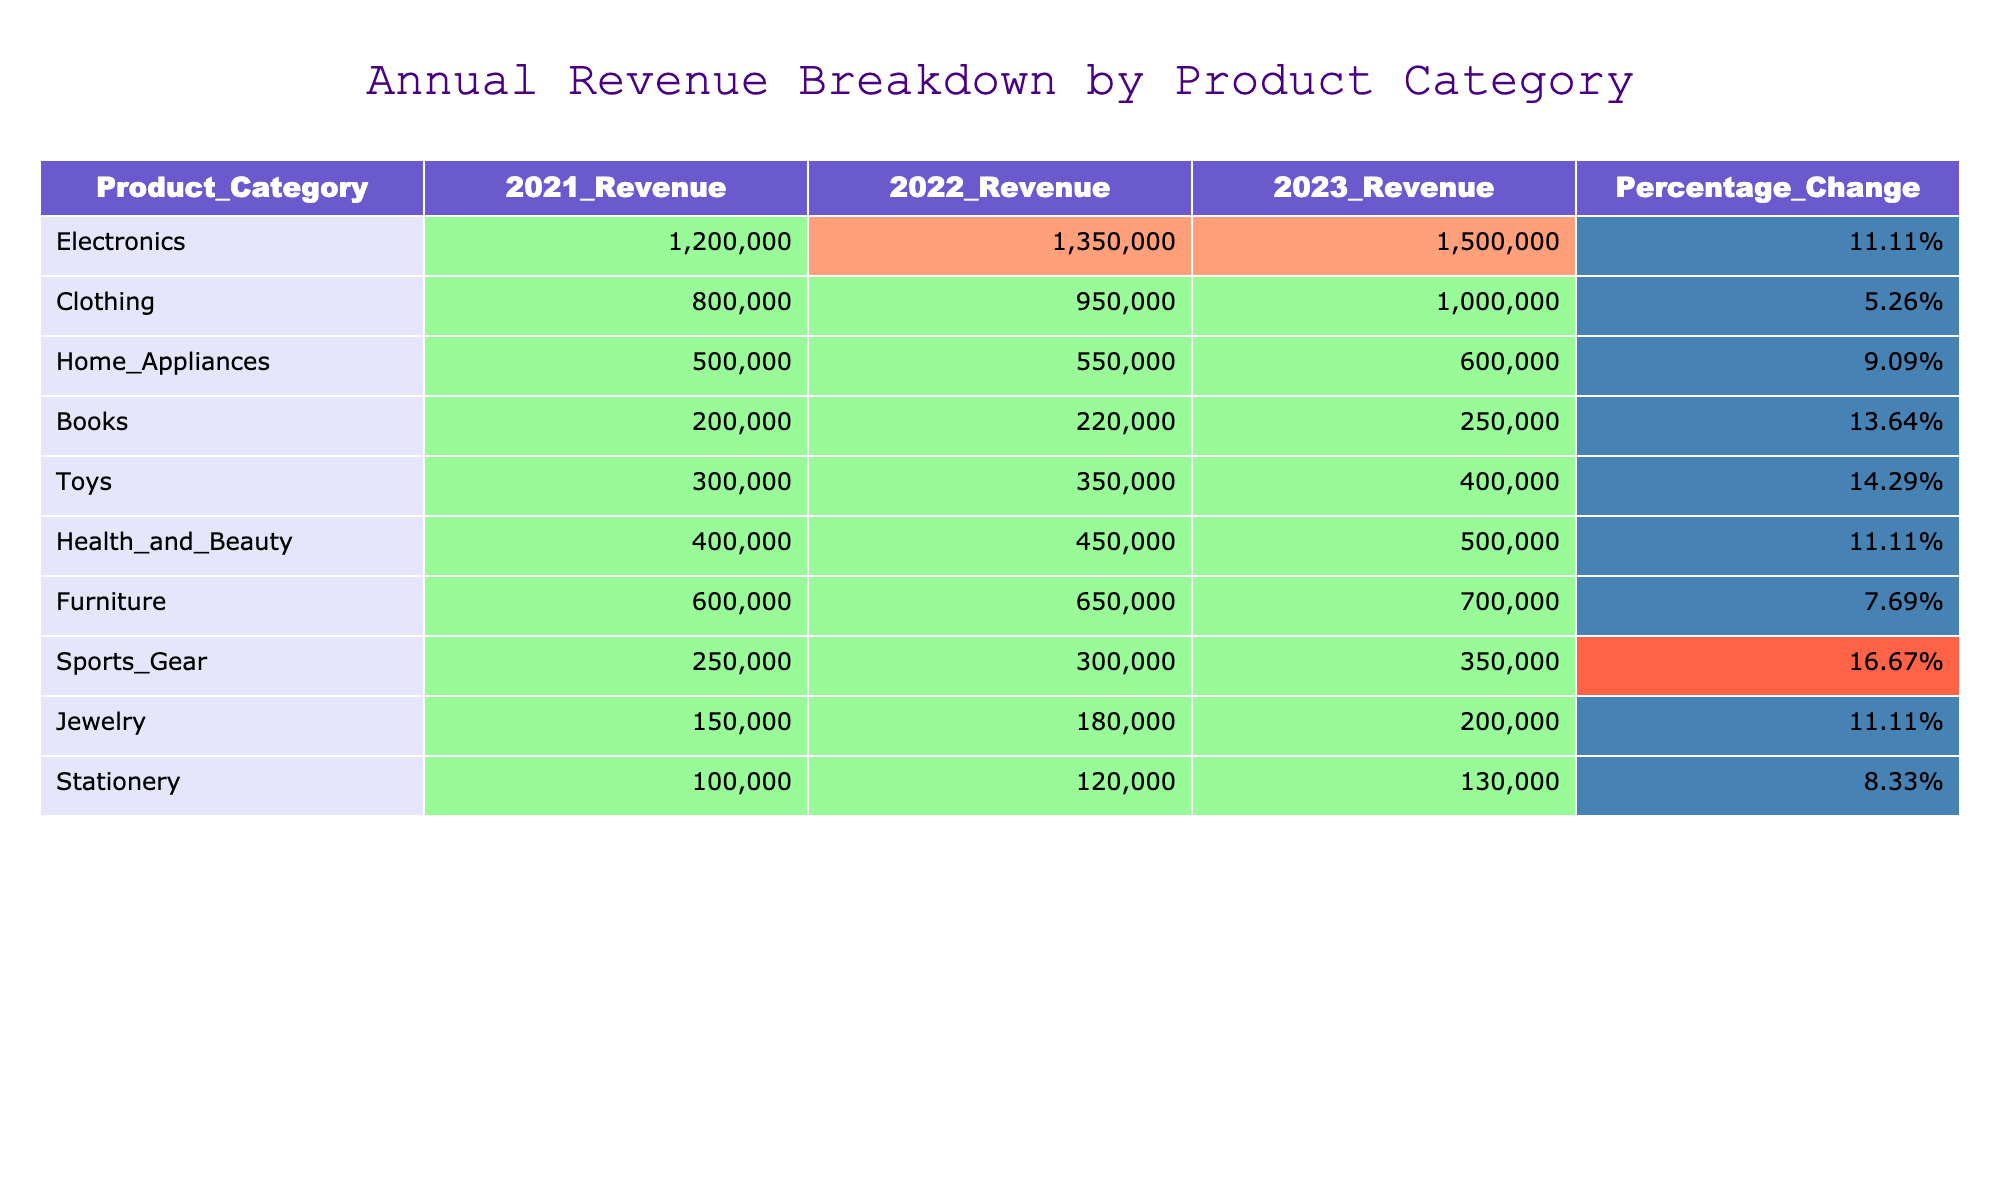What was the highest revenue in 2023 for any product category? Looking at the '2023_Revenue' column, the highest value is 1,500,000 from the Electronics category.
Answer: 1,500,000 Which product category had the lowest percentage change in revenue from 2022 to 2023? The largest percentage change can be found in the 'Percentage_Change' column. The lowest percentage change in this column is 5.26% for the Clothing category.
Answer: 5.26% What is the total revenue for all product categories in 2021? By summing the 2021 revenues: 1,200,000 + 800,000 + 500,000 + 200,000 + 300,000 + 400,000 + 600,000 + 250,000 + 150,000 + 100,000 = 4,650,000.
Answer: 4,650,000 Is the revenue from Books in 2022 greater than the revenue from Sports Gear in 2022? The 2022 revenue for Books is 220,000 while for Sports Gear it is 300,000, making it false that Books has greater revenue than Sports Gear in 2022.
Answer: False What is the average revenue change across all product categories from 2021 to 2023? The percentage changes for each category are calculated and summed, then averaged: (11.11% + 5.26% + 9.09% + 13.64% + 14.29% + 11.11% + 7.69% + 16.67% + 11.11% + 8.33%) / 10 = 10.39%.
Answer: 10.39% Which product categories had revenues exceeding 1,300,000 in 2023? In the '2023_Revenue' column, only the Electronics category exceeds 1,300,000.
Answer: Electronics What is the total revenue for the Health and Beauty category from 2021 to 2023 combined? By adding the revenues from 2021 to 2023 for Health and Beauty: 400,000 + 450,000 + 500,000 = 1,350,000.
Answer: 1,350,000 Is the percentage change for Toys greater than the percentage change for Home Appliances? Comparing the percentages, Toys shows a percentage change of 14.29% while Home Appliances has 9.09%, confirming that Toys has a greater change.
Answer: Yes If we compare the 2021 revenues, which categories had revenues less than the average revenue of 2021 (465,000)? Categories with revenues less than 465,000 from 2021 are Books (200,000), Toys (300,000), Jewelry (150,000), and Stationery (100,000).
Answer: Books, Toys, Jewelry, Stationery What is the percentage increase in revenue for Electronics from 2021 to 2023? The calculation involves: [(1,500,000 - 1,200,000) / 1,200,000] * 100 = 25%, showing the increase in revenue over two years.
Answer: 25% 